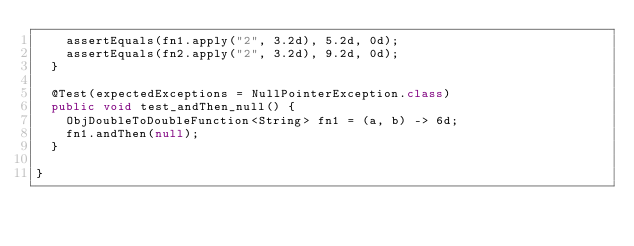Convert code to text. <code><loc_0><loc_0><loc_500><loc_500><_Java_>    assertEquals(fn1.apply("2", 3.2d), 5.2d, 0d);
    assertEquals(fn2.apply("2", 3.2d), 9.2d, 0d);
  }

  @Test(expectedExceptions = NullPointerException.class)
  public void test_andThen_null() {
    ObjDoubleToDoubleFunction<String> fn1 = (a, b) -> 6d;
    fn1.andThen(null);
  }

}
</code> 